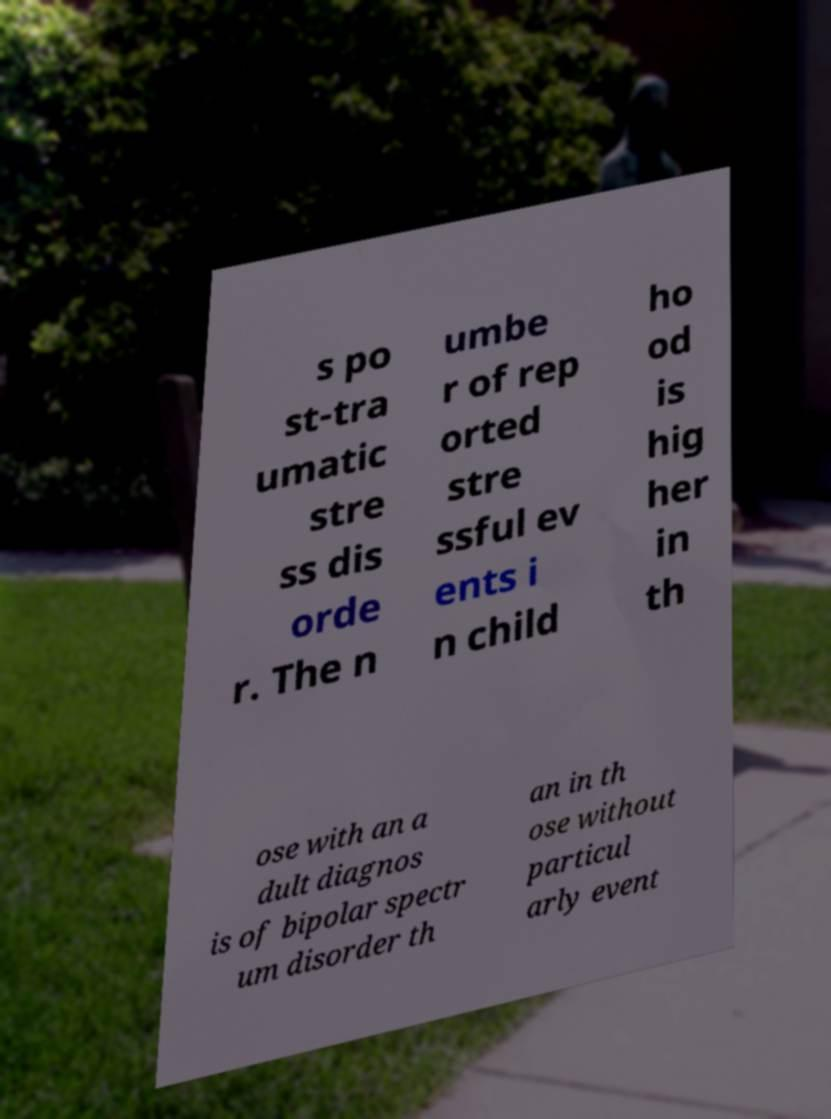Can you read and provide the text displayed in the image?This photo seems to have some interesting text. Can you extract and type it out for me? s po st-tra umatic stre ss dis orde r. The n umbe r of rep orted stre ssful ev ents i n child ho od is hig her in th ose with an a dult diagnos is of bipolar spectr um disorder th an in th ose without particul arly event 